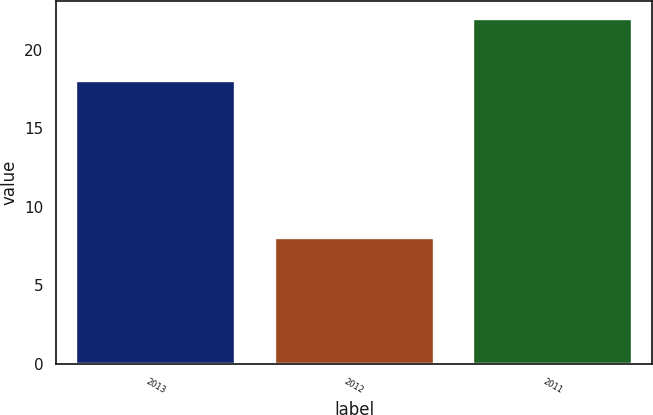<chart> <loc_0><loc_0><loc_500><loc_500><bar_chart><fcel>2013<fcel>2012<fcel>2011<nl><fcel>18<fcel>8<fcel>22<nl></chart> 